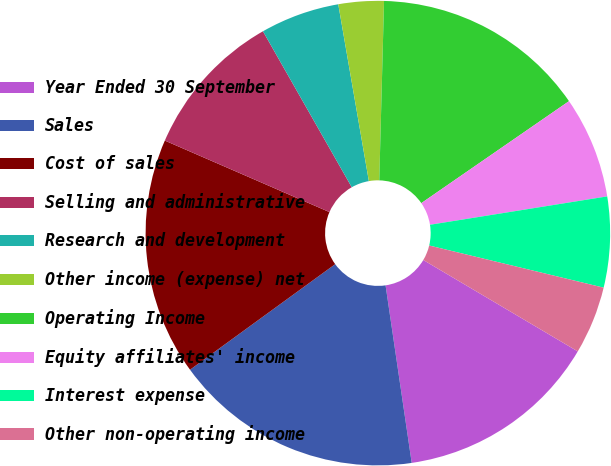Convert chart. <chart><loc_0><loc_0><loc_500><loc_500><pie_chart><fcel>Year Ended 30 September<fcel>Sales<fcel>Cost of sales<fcel>Selling and administrative<fcel>Research and development<fcel>Other income (expense) net<fcel>Operating Income<fcel>Equity affiliates' income<fcel>Interest expense<fcel>Other non-operating income<nl><fcel>14.17%<fcel>17.32%<fcel>16.53%<fcel>10.24%<fcel>5.51%<fcel>3.15%<fcel>14.96%<fcel>7.09%<fcel>6.3%<fcel>4.73%<nl></chart> 